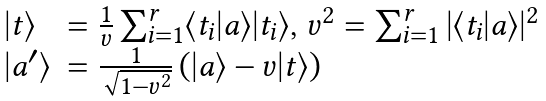Convert formula to latex. <formula><loc_0><loc_0><loc_500><loc_500>\begin{array} { l l } | t \rangle & = \frac { 1 } { v } \sum _ { i = 1 } ^ { r } \langle t _ { i } | a \rangle | t _ { i } \rangle , \, v ^ { 2 } = \sum _ { i = 1 } ^ { r } | \langle t _ { i } | a \rangle | ^ { 2 } \\ | a ^ { \prime } \rangle & = \frac { 1 } { \sqrt { 1 - v ^ { 2 } } } \left ( | a \rangle - v | t \rangle \right ) \end{array}</formula> 